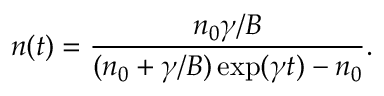<formula> <loc_0><loc_0><loc_500><loc_500>n ( t ) = \frac { n _ { 0 } \gamma / B } { ( n _ { 0 } + \gamma / B ) \exp ( \gamma t ) - n _ { 0 } } .</formula> 